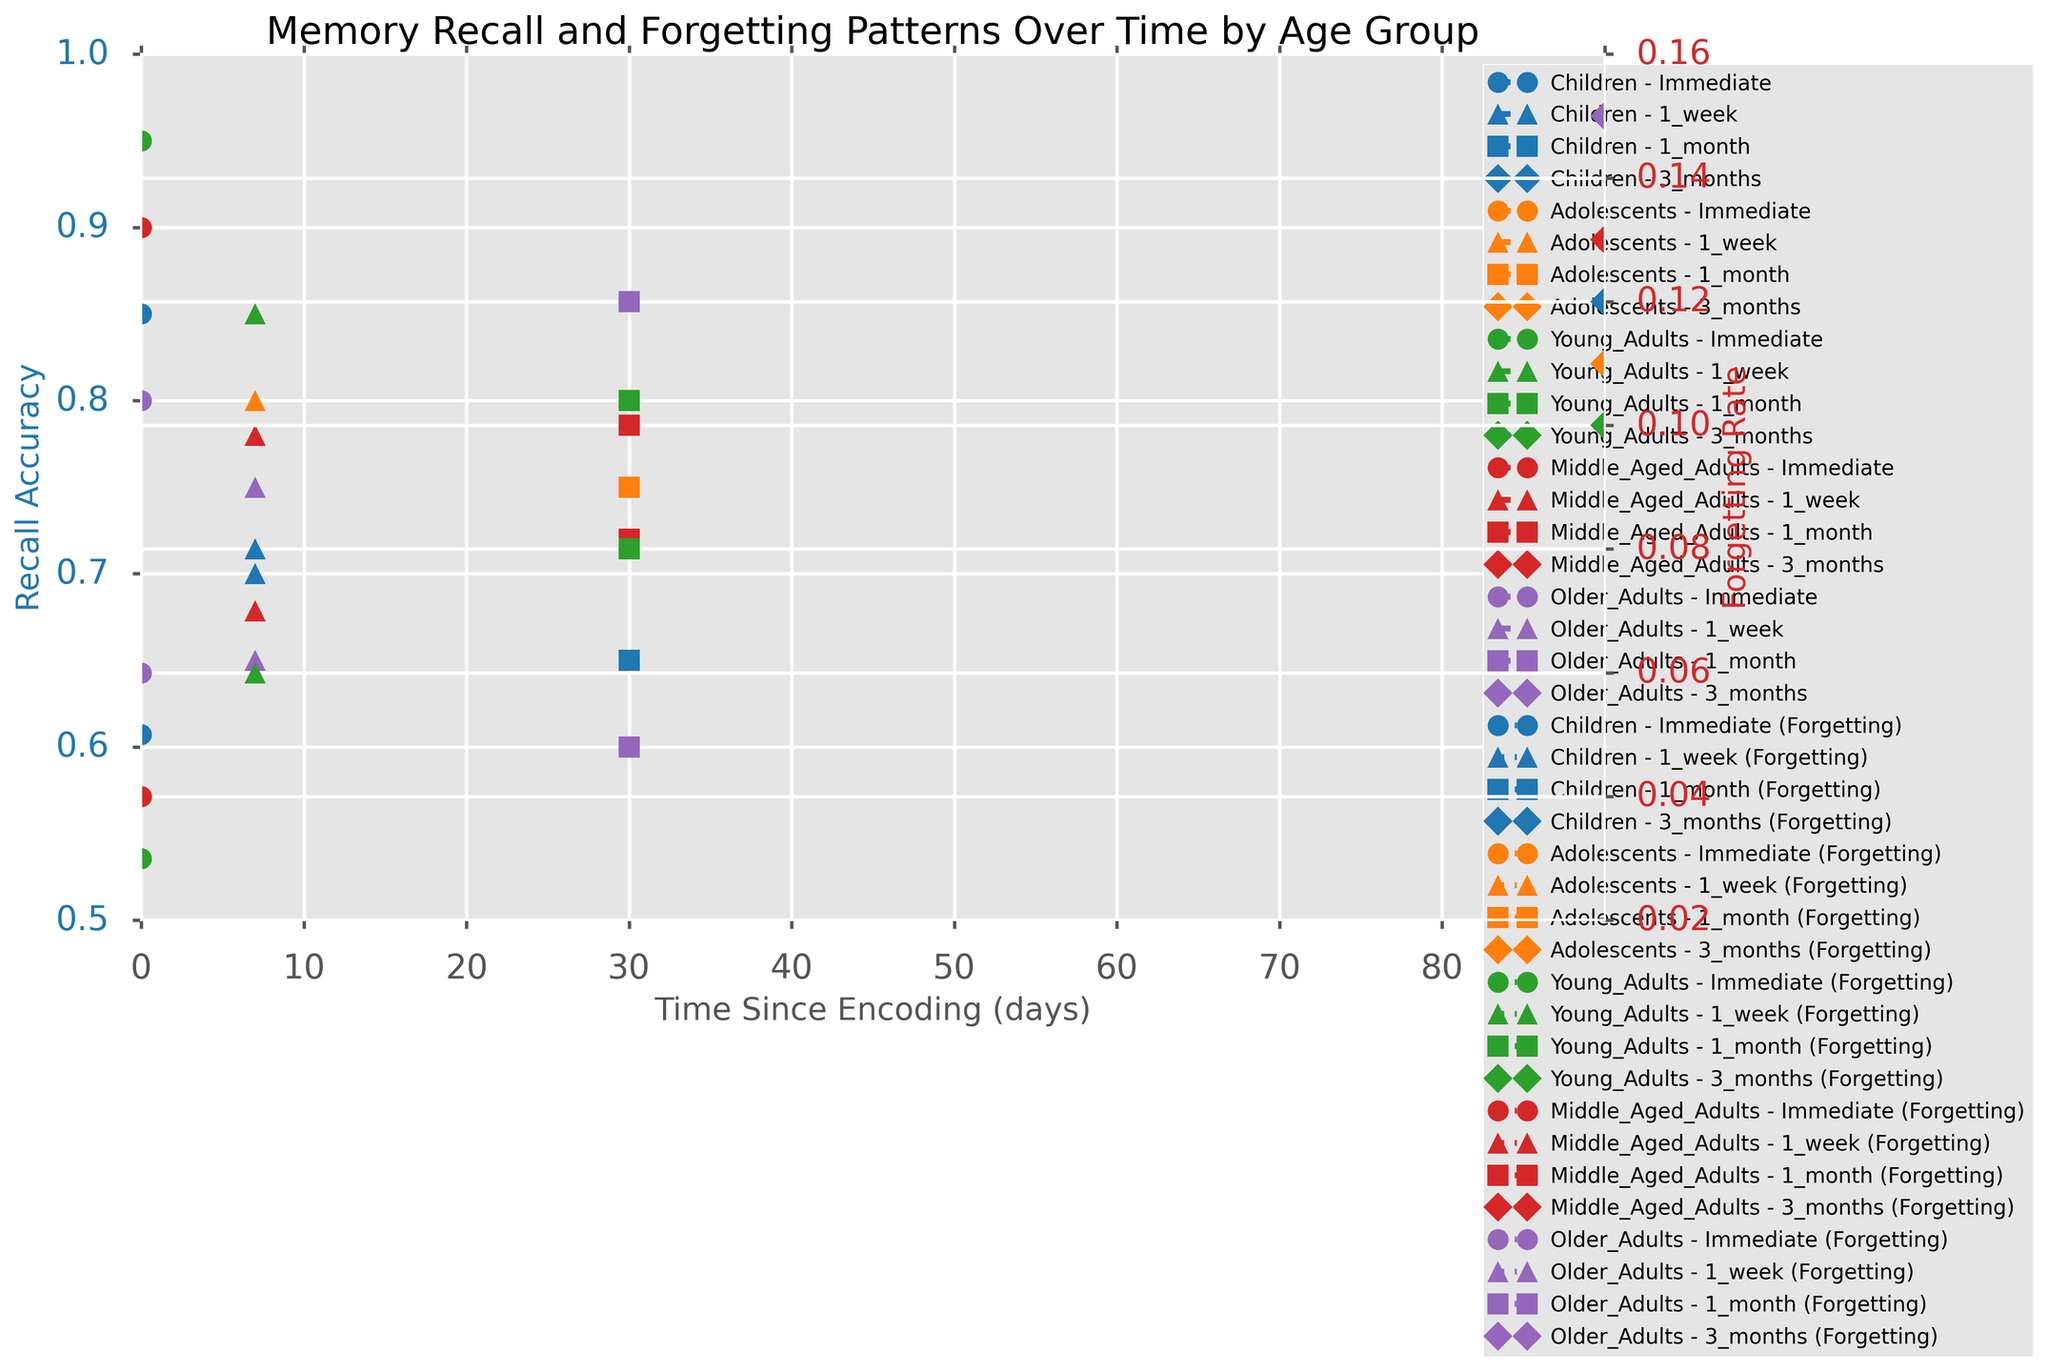What is the trend in recall accuracy for Children over time? First, identify the markers and line colors representing Children. The Children group uses the blue color. Then, observe the recall accuracy values at each time point (Immediate: 0.85, 1_week: 0.70, 1_month: 0.65, 3_months: 0.55). The recall accuracy decreases over time.
Answer: Decreasing Which age group has the highest recall accuracy at the immediate time point? Examine the recall accuracy values at the immediate time point for all age groups (Children: 0.85, Adolescents: 0.90, Young_Adults: 0.95, Middle_Aged_Adults: 0.90, Older_Adults: 0.80). Young Adults have the highest value.
Answer: Young Adults Does the forgetting rate for Older Adults increase or decrease over time? Identify the forgetting rate values for Older Adults at each time point (Immediate: 0.06, 1_week: 0.09, 1_month: 0.12, 3_months: 0.15). The values show an increasing trend over time.
Answer: Increasing What is the difference in recall accuracy between Adolescents and Middle-Aged Adults at the 3-month mark? Find the recall accuracy values at the 3-month point (Adolescents: 0.70, Middle_Aged_Adults: 0.65). Calculate the difference: 0.70 - 0.65 = 0.05.
Answer: 0.05 Which group shows the lowest forgetting rate at the 1-week mark? Check the forgetting rate values for each age group at the 1-week mark (Children: 0.08, Adolescents: 0.07, Young_Adults: 0.06, Middle_Aged_Adults: 0.07, Older_Adults: 0.09). Young Adults have the lowest value at 0.06.
Answer: Young Adults How does the recall accuracy of Young Adults compare with Children at 1 month? Compare the recall accuracy values for Young Adults (0.80) and Children (0.65) at the 1-month time point. Young Adults have a higher recall accuracy.
Answer: Higher What is the average recall accuracy for Middle-Aged Adults across all time points? Calculate the average of recall accuracy values for Middle-Aged Adults at all time points (Immediate: 0.90, 1_week: 0.78, 1_month: 0.72, 3_months: 0.65). Sum these values (0.90 + 0.78 + 0.72 + 0.65) = 3.05, then divide by 4 (number of points): 3.05 / 4 = 0.7625.
Answer: 0.7625 Which age group has the fastest increase in forgetting rate over time? Calculate the difference in forgetting rates from immediate to 3 months for each age group: Children (0.12 - 0.05 = 0.07), Adolescents (0.11 - 0.04 = 0.07), Young Adults (0.10 - 0.03 = 0.07), Middle-Aged Adults (0.13 - 0.04 = 0.09), Older Adults (0.15 - 0.06 = 0.09). Both Middle-Aged Adults and Older Adults have the highest increase of 0.09.
Answer: Middle-Aged Adults and Older Adults 